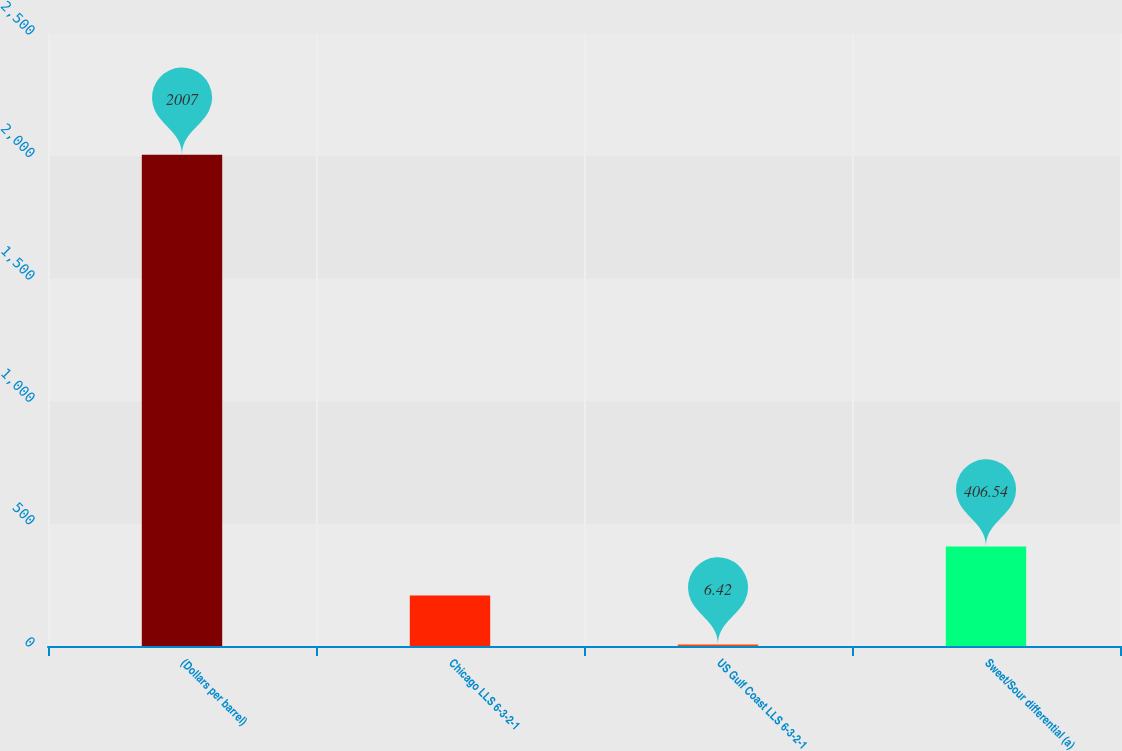<chart> <loc_0><loc_0><loc_500><loc_500><bar_chart><fcel>(Dollars per barrel)<fcel>Chicago LLS 6-3-2-1<fcel>US Gulf Coast LLS 6-3-2-1<fcel>Sweet/Sour differential (a)<nl><fcel>2007<fcel>206.48<fcel>6.42<fcel>406.54<nl></chart> 